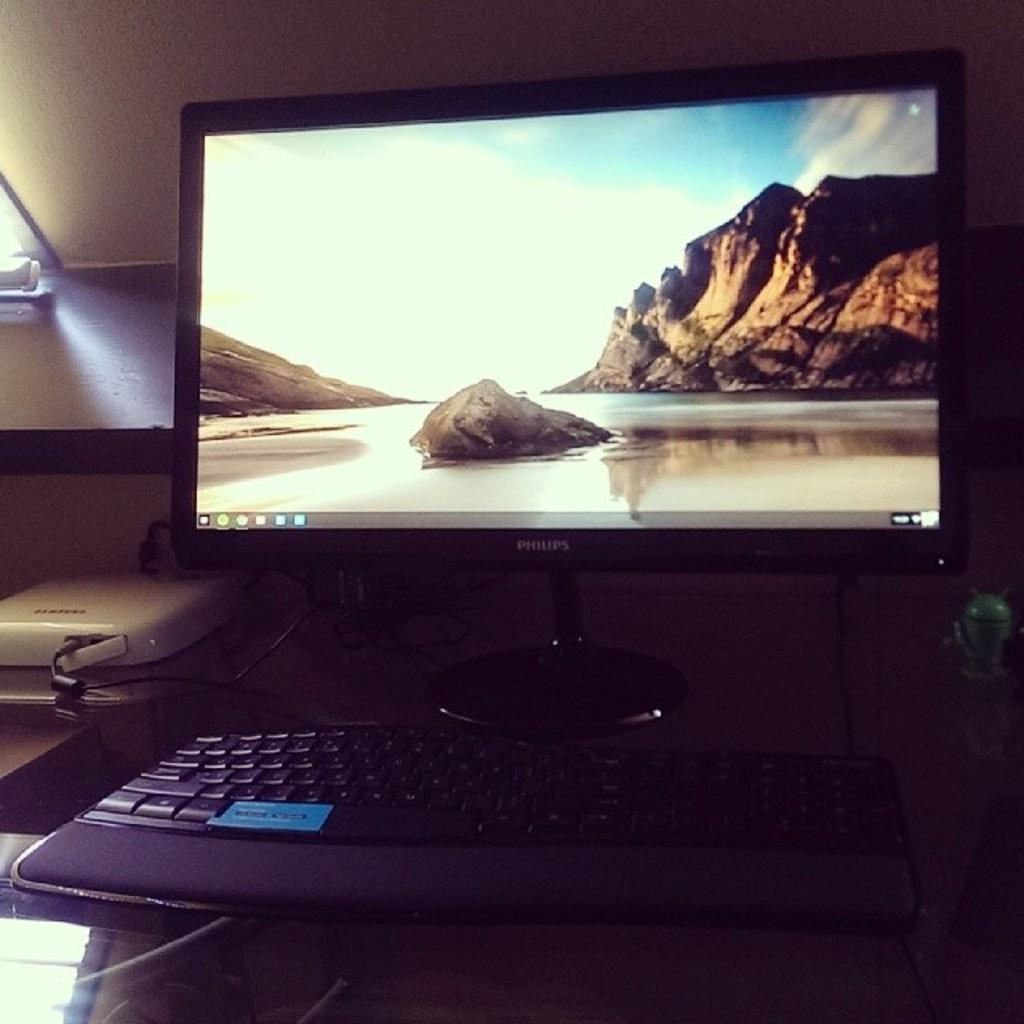<image>
Provide a brief description of the given image. A Philips computer monitor with a beach scene background sits on a desk. 